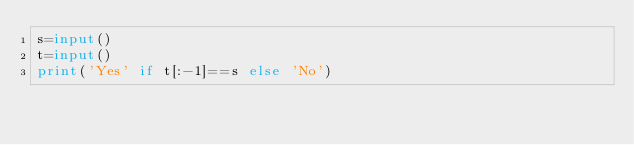Convert code to text. <code><loc_0><loc_0><loc_500><loc_500><_Python_>s=input()
t=input()
print('Yes' if t[:-1]==s else 'No')</code> 